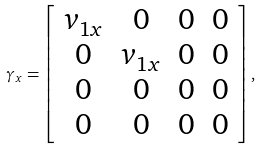<formula> <loc_0><loc_0><loc_500><loc_500>\gamma _ { x } = \left [ \begin{array} { c c c c } v _ { 1 x } & 0 & 0 & 0 \\ 0 & v _ { 1 x } & 0 & 0 \\ 0 & 0 & 0 & 0 \\ 0 & 0 & 0 & 0 \end{array} \right ] ,</formula> 